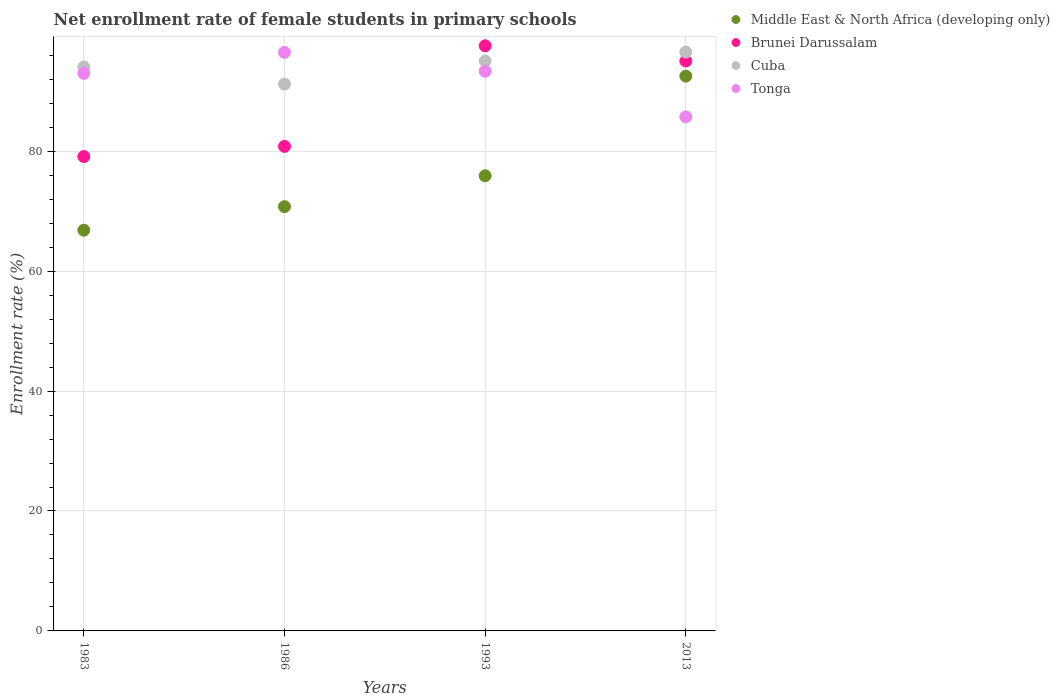Is the number of dotlines equal to the number of legend labels?
Your answer should be compact. Yes. What is the net enrollment rate of female students in primary schools in Brunei Darussalam in 2013?
Your answer should be very brief. 95.04. Across all years, what is the maximum net enrollment rate of female students in primary schools in Brunei Darussalam?
Keep it short and to the point. 97.58. Across all years, what is the minimum net enrollment rate of female students in primary schools in Tonga?
Provide a short and direct response. 85.73. In which year was the net enrollment rate of female students in primary schools in Brunei Darussalam maximum?
Provide a short and direct response. 1993. What is the total net enrollment rate of female students in primary schools in Cuba in the graph?
Provide a succinct answer. 376.82. What is the difference between the net enrollment rate of female students in primary schools in Tonga in 1993 and that in 2013?
Make the answer very short. 7.61. What is the difference between the net enrollment rate of female students in primary schools in Middle East & North Africa (developing only) in 1993 and the net enrollment rate of female students in primary schools in Cuba in 2013?
Your response must be concise. -20.64. What is the average net enrollment rate of female students in primary schools in Cuba per year?
Your response must be concise. 94.21. In the year 1986, what is the difference between the net enrollment rate of female students in primary schools in Cuba and net enrollment rate of female students in primary schools in Middle East & North Africa (developing only)?
Keep it short and to the point. 20.44. In how many years, is the net enrollment rate of female students in primary schools in Cuba greater than 36 %?
Make the answer very short. 4. What is the ratio of the net enrollment rate of female students in primary schools in Tonga in 1986 to that in 1993?
Give a very brief answer. 1.03. What is the difference between the highest and the second highest net enrollment rate of female students in primary schools in Tonga?
Provide a succinct answer. 3.15. What is the difference between the highest and the lowest net enrollment rate of female students in primary schools in Middle East & North Africa (developing only)?
Your response must be concise. 25.69. Is the sum of the net enrollment rate of female students in primary schools in Cuba in 1983 and 2013 greater than the maximum net enrollment rate of female students in primary schools in Brunei Darussalam across all years?
Your answer should be very brief. Yes. Is it the case that in every year, the sum of the net enrollment rate of female students in primary schools in Tonga and net enrollment rate of female students in primary schools in Middle East & North Africa (developing only)  is greater than the sum of net enrollment rate of female students in primary schools in Brunei Darussalam and net enrollment rate of female students in primary schools in Cuba?
Your response must be concise. Yes. Is it the case that in every year, the sum of the net enrollment rate of female students in primary schools in Middle East & North Africa (developing only) and net enrollment rate of female students in primary schools in Brunei Darussalam  is greater than the net enrollment rate of female students in primary schools in Tonga?
Your response must be concise. Yes. Does the net enrollment rate of female students in primary schools in Brunei Darussalam monotonically increase over the years?
Your response must be concise. No. Is the net enrollment rate of female students in primary schools in Cuba strictly less than the net enrollment rate of female students in primary schools in Tonga over the years?
Offer a very short reply. No. How many dotlines are there?
Give a very brief answer. 4. How many years are there in the graph?
Your answer should be compact. 4. Does the graph contain grids?
Your response must be concise. Yes. How are the legend labels stacked?
Your answer should be very brief. Vertical. What is the title of the graph?
Provide a succinct answer. Net enrollment rate of female students in primary schools. Does "Portugal" appear as one of the legend labels in the graph?
Ensure brevity in your answer.  No. What is the label or title of the Y-axis?
Give a very brief answer. Enrollment rate (%). What is the Enrollment rate (%) in Middle East & North Africa (developing only) in 1983?
Provide a short and direct response. 66.83. What is the Enrollment rate (%) in Brunei Darussalam in 1983?
Your response must be concise. 79.11. What is the Enrollment rate (%) in Cuba in 1983?
Make the answer very short. 94.05. What is the Enrollment rate (%) of Tonga in 1983?
Keep it short and to the point. 92.98. What is the Enrollment rate (%) in Middle East & North Africa (developing only) in 1986?
Keep it short and to the point. 70.76. What is the Enrollment rate (%) in Brunei Darussalam in 1986?
Keep it short and to the point. 80.81. What is the Enrollment rate (%) in Cuba in 1986?
Offer a very short reply. 91.2. What is the Enrollment rate (%) in Tonga in 1986?
Offer a terse response. 96.49. What is the Enrollment rate (%) of Middle East & North Africa (developing only) in 1993?
Keep it short and to the point. 75.91. What is the Enrollment rate (%) of Brunei Darussalam in 1993?
Your response must be concise. 97.58. What is the Enrollment rate (%) in Cuba in 1993?
Your answer should be very brief. 95.04. What is the Enrollment rate (%) in Tonga in 1993?
Your response must be concise. 93.34. What is the Enrollment rate (%) in Middle East & North Africa (developing only) in 2013?
Keep it short and to the point. 92.52. What is the Enrollment rate (%) of Brunei Darussalam in 2013?
Provide a short and direct response. 95.04. What is the Enrollment rate (%) of Cuba in 2013?
Give a very brief answer. 96.54. What is the Enrollment rate (%) of Tonga in 2013?
Your answer should be very brief. 85.73. Across all years, what is the maximum Enrollment rate (%) of Middle East & North Africa (developing only)?
Your response must be concise. 92.52. Across all years, what is the maximum Enrollment rate (%) in Brunei Darussalam?
Ensure brevity in your answer.  97.58. Across all years, what is the maximum Enrollment rate (%) of Cuba?
Ensure brevity in your answer.  96.54. Across all years, what is the maximum Enrollment rate (%) in Tonga?
Provide a succinct answer. 96.49. Across all years, what is the minimum Enrollment rate (%) of Middle East & North Africa (developing only)?
Keep it short and to the point. 66.83. Across all years, what is the minimum Enrollment rate (%) in Brunei Darussalam?
Provide a short and direct response. 79.11. Across all years, what is the minimum Enrollment rate (%) in Cuba?
Your answer should be compact. 91.2. Across all years, what is the minimum Enrollment rate (%) of Tonga?
Keep it short and to the point. 85.73. What is the total Enrollment rate (%) of Middle East & North Africa (developing only) in the graph?
Offer a terse response. 306.01. What is the total Enrollment rate (%) of Brunei Darussalam in the graph?
Provide a succinct answer. 352.55. What is the total Enrollment rate (%) of Cuba in the graph?
Keep it short and to the point. 376.82. What is the total Enrollment rate (%) of Tonga in the graph?
Provide a short and direct response. 368.54. What is the difference between the Enrollment rate (%) of Middle East & North Africa (developing only) in 1983 and that in 1986?
Give a very brief answer. -3.93. What is the difference between the Enrollment rate (%) of Brunei Darussalam in 1983 and that in 1986?
Ensure brevity in your answer.  -1.7. What is the difference between the Enrollment rate (%) in Cuba in 1983 and that in 1986?
Keep it short and to the point. 2.85. What is the difference between the Enrollment rate (%) in Tonga in 1983 and that in 1986?
Make the answer very short. -3.51. What is the difference between the Enrollment rate (%) in Middle East & North Africa (developing only) in 1983 and that in 1993?
Provide a succinct answer. -9.08. What is the difference between the Enrollment rate (%) in Brunei Darussalam in 1983 and that in 1993?
Ensure brevity in your answer.  -18.47. What is the difference between the Enrollment rate (%) in Cuba in 1983 and that in 1993?
Provide a succinct answer. -0.99. What is the difference between the Enrollment rate (%) in Tonga in 1983 and that in 1993?
Make the answer very short. -0.36. What is the difference between the Enrollment rate (%) in Middle East & North Africa (developing only) in 1983 and that in 2013?
Keep it short and to the point. -25.69. What is the difference between the Enrollment rate (%) of Brunei Darussalam in 1983 and that in 2013?
Offer a terse response. -15.93. What is the difference between the Enrollment rate (%) of Cuba in 1983 and that in 2013?
Provide a short and direct response. -2.5. What is the difference between the Enrollment rate (%) in Tonga in 1983 and that in 2013?
Offer a very short reply. 7.25. What is the difference between the Enrollment rate (%) in Middle East & North Africa (developing only) in 1986 and that in 1993?
Ensure brevity in your answer.  -5.15. What is the difference between the Enrollment rate (%) in Brunei Darussalam in 1986 and that in 1993?
Provide a succinct answer. -16.77. What is the difference between the Enrollment rate (%) in Cuba in 1986 and that in 1993?
Ensure brevity in your answer.  -3.84. What is the difference between the Enrollment rate (%) in Tonga in 1986 and that in 1993?
Make the answer very short. 3.15. What is the difference between the Enrollment rate (%) in Middle East & North Africa (developing only) in 1986 and that in 2013?
Keep it short and to the point. -21.77. What is the difference between the Enrollment rate (%) in Brunei Darussalam in 1986 and that in 2013?
Make the answer very short. -14.23. What is the difference between the Enrollment rate (%) in Cuba in 1986 and that in 2013?
Provide a short and direct response. -5.35. What is the difference between the Enrollment rate (%) in Tonga in 1986 and that in 2013?
Keep it short and to the point. 10.76. What is the difference between the Enrollment rate (%) of Middle East & North Africa (developing only) in 1993 and that in 2013?
Your answer should be very brief. -16.61. What is the difference between the Enrollment rate (%) in Brunei Darussalam in 1993 and that in 2013?
Keep it short and to the point. 2.54. What is the difference between the Enrollment rate (%) of Cuba in 1993 and that in 2013?
Provide a short and direct response. -1.51. What is the difference between the Enrollment rate (%) in Tonga in 1993 and that in 2013?
Ensure brevity in your answer.  7.61. What is the difference between the Enrollment rate (%) of Middle East & North Africa (developing only) in 1983 and the Enrollment rate (%) of Brunei Darussalam in 1986?
Ensure brevity in your answer.  -13.98. What is the difference between the Enrollment rate (%) of Middle East & North Africa (developing only) in 1983 and the Enrollment rate (%) of Cuba in 1986?
Ensure brevity in your answer.  -24.37. What is the difference between the Enrollment rate (%) in Middle East & North Africa (developing only) in 1983 and the Enrollment rate (%) in Tonga in 1986?
Give a very brief answer. -29.66. What is the difference between the Enrollment rate (%) in Brunei Darussalam in 1983 and the Enrollment rate (%) in Cuba in 1986?
Keep it short and to the point. -12.08. What is the difference between the Enrollment rate (%) of Brunei Darussalam in 1983 and the Enrollment rate (%) of Tonga in 1986?
Provide a short and direct response. -17.38. What is the difference between the Enrollment rate (%) in Cuba in 1983 and the Enrollment rate (%) in Tonga in 1986?
Your response must be concise. -2.44. What is the difference between the Enrollment rate (%) in Middle East & North Africa (developing only) in 1983 and the Enrollment rate (%) in Brunei Darussalam in 1993?
Keep it short and to the point. -30.75. What is the difference between the Enrollment rate (%) of Middle East & North Africa (developing only) in 1983 and the Enrollment rate (%) of Cuba in 1993?
Make the answer very short. -28.21. What is the difference between the Enrollment rate (%) of Middle East & North Africa (developing only) in 1983 and the Enrollment rate (%) of Tonga in 1993?
Give a very brief answer. -26.51. What is the difference between the Enrollment rate (%) in Brunei Darussalam in 1983 and the Enrollment rate (%) in Cuba in 1993?
Your answer should be compact. -15.92. What is the difference between the Enrollment rate (%) in Brunei Darussalam in 1983 and the Enrollment rate (%) in Tonga in 1993?
Offer a terse response. -14.23. What is the difference between the Enrollment rate (%) in Cuba in 1983 and the Enrollment rate (%) in Tonga in 1993?
Keep it short and to the point. 0.71. What is the difference between the Enrollment rate (%) in Middle East & North Africa (developing only) in 1983 and the Enrollment rate (%) in Brunei Darussalam in 2013?
Provide a succinct answer. -28.21. What is the difference between the Enrollment rate (%) of Middle East & North Africa (developing only) in 1983 and the Enrollment rate (%) of Cuba in 2013?
Provide a short and direct response. -29.72. What is the difference between the Enrollment rate (%) in Middle East & North Africa (developing only) in 1983 and the Enrollment rate (%) in Tonga in 2013?
Provide a short and direct response. -18.9. What is the difference between the Enrollment rate (%) of Brunei Darussalam in 1983 and the Enrollment rate (%) of Cuba in 2013?
Keep it short and to the point. -17.43. What is the difference between the Enrollment rate (%) of Brunei Darussalam in 1983 and the Enrollment rate (%) of Tonga in 2013?
Provide a short and direct response. -6.62. What is the difference between the Enrollment rate (%) in Cuba in 1983 and the Enrollment rate (%) in Tonga in 2013?
Offer a very short reply. 8.32. What is the difference between the Enrollment rate (%) in Middle East & North Africa (developing only) in 1986 and the Enrollment rate (%) in Brunei Darussalam in 1993?
Your answer should be compact. -26.83. What is the difference between the Enrollment rate (%) of Middle East & North Africa (developing only) in 1986 and the Enrollment rate (%) of Cuba in 1993?
Provide a short and direct response. -24.28. What is the difference between the Enrollment rate (%) in Middle East & North Africa (developing only) in 1986 and the Enrollment rate (%) in Tonga in 1993?
Your response must be concise. -22.59. What is the difference between the Enrollment rate (%) of Brunei Darussalam in 1986 and the Enrollment rate (%) of Cuba in 1993?
Ensure brevity in your answer.  -14.23. What is the difference between the Enrollment rate (%) of Brunei Darussalam in 1986 and the Enrollment rate (%) of Tonga in 1993?
Offer a very short reply. -12.53. What is the difference between the Enrollment rate (%) in Cuba in 1986 and the Enrollment rate (%) in Tonga in 1993?
Your answer should be compact. -2.15. What is the difference between the Enrollment rate (%) in Middle East & North Africa (developing only) in 1986 and the Enrollment rate (%) in Brunei Darussalam in 2013?
Provide a short and direct response. -24.29. What is the difference between the Enrollment rate (%) in Middle East & North Africa (developing only) in 1986 and the Enrollment rate (%) in Cuba in 2013?
Offer a terse response. -25.79. What is the difference between the Enrollment rate (%) in Middle East & North Africa (developing only) in 1986 and the Enrollment rate (%) in Tonga in 2013?
Give a very brief answer. -14.98. What is the difference between the Enrollment rate (%) of Brunei Darussalam in 1986 and the Enrollment rate (%) of Cuba in 2013?
Ensure brevity in your answer.  -15.74. What is the difference between the Enrollment rate (%) of Brunei Darussalam in 1986 and the Enrollment rate (%) of Tonga in 2013?
Make the answer very short. -4.92. What is the difference between the Enrollment rate (%) in Cuba in 1986 and the Enrollment rate (%) in Tonga in 2013?
Provide a succinct answer. 5.46. What is the difference between the Enrollment rate (%) in Middle East & North Africa (developing only) in 1993 and the Enrollment rate (%) in Brunei Darussalam in 2013?
Provide a short and direct response. -19.13. What is the difference between the Enrollment rate (%) in Middle East & North Africa (developing only) in 1993 and the Enrollment rate (%) in Cuba in 2013?
Make the answer very short. -20.64. What is the difference between the Enrollment rate (%) of Middle East & North Africa (developing only) in 1993 and the Enrollment rate (%) of Tonga in 2013?
Give a very brief answer. -9.82. What is the difference between the Enrollment rate (%) in Brunei Darussalam in 1993 and the Enrollment rate (%) in Cuba in 2013?
Your response must be concise. 1.04. What is the difference between the Enrollment rate (%) of Brunei Darussalam in 1993 and the Enrollment rate (%) of Tonga in 2013?
Give a very brief answer. 11.85. What is the difference between the Enrollment rate (%) in Cuba in 1993 and the Enrollment rate (%) in Tonga in 2013?
Provide a succinct answer. 9.3. What is the average Enrollment rate (%) in Middle East & North Africa (developing only) per year?
Give a very brief answer. 76.5. What is the average Enrollment rate (%) of Brunei Darussalam per year?
Keep it short and to the point. 88.14. What is the average Enrollment rate (%) of Cuba per year?
Provide a short and direct response. 94.21. What is the average Enrollment rate (%) of Tonga per year?
Your response must be concise. 92.14. In the year 1983, what is the difference between the Enrollment rate (%) in Middle East & North Africa (developing only) and Enrollment rate (%) in Brunei Darussalam?
Offer a very short reply. -12.28. In the year 1983, what is the difference between the Enrollment rate (%) in Middle East & North Africa (developing only) and Enrollment rate (%) in Cuba?
Make the answer very short. -27.22. In the year 1983, what is the difference between the Enrollment rate (%) of Middle East & North Africa (developing only) and Enrollment rate (%) of Tonga?
Your answer should be compact. -26.15. In the year 1983, what is the difference between the Enrollment rate (%) in Brunei Darussalam and Enrollment rate (%) in Cuba?
Make the answer very short. -14.94. In the year 1983, what is the difference between the Enrollment rate (%) in Brunei Darussalam and Enrollment rate (%) in Tonga?
Offer a terse response. -13.87. In the year 1983, what is the difference between the Enrollment rate (%) in Cuba and Enrollment rate (%) in Tonga?
Provide a succinct answer. 1.07. In the year 1986, what is the difference between the Enrollment rate (%) in Middle East & North Africa (developing only) and Enrollment rate (%) in Brunei Darussalam?
Ensure brevity in your answer.  -10.05. In the year 1986, what is the difference between the Enrollment rate (%) of Middle East & North Africa (developing only) and Enrollment rate (%) of Cuba?
Provide a succinct answer. -20.44. In the year 1986, what is the difference between the Enrollment rate (%) of Middle East & North Africa (developing only) and Enrollment rate (%) of Tonga?
Provide a succinct answer. -25.73. In the year 1986, what is the difference between the Enrollment rate (%) in Brunei Darussalam and Enrollment rate (%) in Cuba?
Offer a terse response. -10.39. In the year 1986, what is the difference between the Enrollment rate (%) of Brunei Darussalam and Enrollment rate (%) of Tonga?
Ensure brevity in your answer.  -15.68. In the year 1986, what is the difference between the Enrollment rate (%) of Cuba and Enrollment rate (%) of Tonga?
Keep it short and to the point. -5.29. In the year 1993, what is the difference between the Enrollment rate (%) in Middle East & North Africa (developing only) and Enrollment rate (%) in Brunei Darussalam?
Your answer should be compact. -21.68. In the year 1993, what is the difference between the Enrollment rate (%) in Middle East & North Africa (developing only) and Enrollment rate (%) in Cuba?
Give a very brief answer. -19.13. In the year 1993, what is the difference between the Enrollment rate (%) of Middle East & North Africa (developing only) and Enrollment rate (%) of Tonga?
Provide a short and direct response. -17.43. In the year 1993, what is the difference between the Enrollment rate (%) of Brunei Darussalam and Enrollment rate (%) of Cuba?
Give a very brief answer. 2.55. In the year 1993, what is the difference between the Enrollment rate (%) of Brunei Darussalam and Enrollment rate (%) of Tonga?
Your response must be concise. 4.24. In the year 1993, what is the difference between the Enrollment rate (%) in Cuba and Enrollment rate (%) in Tonga?
Offer a terse response. 1.69. In the year 2013, what is the difference between the Enrollment rate (%) of Middle East & North Africa (developing only) and Enrollment rate (%) of Brunei Darussalam?
Your response must be concise. -2.52. In the year 2013, what is the difference between the Enrollment rate (%) in Middle East & North Africa (developing only) and Enrollment rate (%) in Cuba?
Provide a short and direct response. -4.02. In the year 2013, what is the difference between the Enrollment rate (%) of Middle East & North Africa (developing only) and Enrollment rate (%) of Tonga?
Offer a terse response. 6.79. In the year 2013, what is the difference between the Enrollment rate (%) of Brunei Darussalam and Enrollment rate (%) of Cuba?
Give a very brief answer. -1.5. In the year 2013, what is the difference between the Enrollment rate (%) in Brunei Darussalam and Enrollment rate (%) in Tonga?
Give a very brief answer. 9.31. In the year 2013, what is the difference between the Enrollment rate (%) of Cuba and Enrollment rate (%) of Tonga?
Keep it short and to the point. 10.81. What is the ratio of the Enrollment rate (%) of Middle East & North Africa (developing only) in 1983 to that in 1986?
Offer a terse response. 0.94. What is the ratio of the Enrollment rate (%) in Brunei Darussalam in 1983 to that in 1986?
Keep it short and to the point. 0.98. What is the ratio of the Enrollment rate (%) of Cuba in 1983 to that in 1986?
Provide a succinct answer. 1.03. What is the ratio of the Enrollment rate (%) in Tonga in 1983 to that in 1986?
Offer a very short reply. 0.96. What is the ratio of the Enrollment rate (%) in Middle East & North Africa (developing only) in 1983 to that in 1993?
Your answer should be compact. 0.88. What is the ratio of the Enrollment rate (%) in Brunei Darussalam in 1983 to that in 1993?
Provide a succinct answer. 0.81. What is the ratio of the Enrollment rate (%) in Middle East & North Africa (developing only) in 1983 to that in 2013?
Keep it short and to the point. 0.72. What is the ratio of the Enrollment rate (%) of Brunei Darussalam in 1983 to that in 2013?
Ensure brevity in your answer.  0.83. What is the ratio of the Enrollment rate (%) in Cuba in 1983 to that in 2013?
Give a very brief answer. 0.97. What is the ratio of the Enrollment rate (%) in Tonga in 1983 to that in 2013?
Give a very brief answer. 1.08. What is the ratio of the Enrollment rate (%) in Middle East & North Africa (developing only) in 1986 to that in 1993?
Keep it short and to the point. 0.93. What is the ratio of the Enrollment rate (%) of Brunei Darussalam in 1986 to that in 1993?
Your answer should be very brief. 0.83. What is the ratio of the Enrollment rate (%) in Cuba in 1986 to that in 1993?
Offer a terse response. 0.96. What is the ratio of the Enrollment rate (%) in Tonga in 1986 to that in 1993?
Offer a terse response. 1.03. What is the ratio of the Enrollment rate (%) of Middle East & North Africa (developing only) in 1986 to that in 2013?
Give a very brief answer. 0.76. What is the ratio of the Enrollment rate (%) of Brunei Darussalam in 1986 to that in 2013?
Provide a succinct answer. 0.85. What is the ratio of the Enrollment rate (%) in Cuba in 1986 to that in 2013?
Offer a very short reply. 0.94. What is the ratio of the Enrollment rate (%) in Tonga in 1986 to that in 2013?
Keep it short and to the point. 1.13. What is the ratio of the Enrollment rate (%) in Middle East & North Africa (developing only) in 1993 to that in 2013?
Provide a succinct answer. 0.82. What is the ratio of the Enrollment rate (%) in Brunei Darussalam in 1993 to that in 2013?
Your response must be concise. 1.03. What is the ratio of the Enrollment rate (%) of Cuba in 1993 to that in 2013?
Your response must be concise. 0.98. What is the ratio of the Enrollment rate (%) of Tonga in 1993 to that in 2013?
Provide a succinct answer. 1.09. What is the difference between the highest and the second highest Enrollment rate (%) of Middle East & North Africa (developing only)?
Offer a very short reply. 16.61. What is the difference between the highest and the second highest Enrollment rate (%) in Brunei Darussalam?
Your response must be concise. 2.54. What is the difference between the highest and the second highest Enrollment rate (%) in Cuba?
Make the answer very short. 1.51. What is the difference between the highest and the second highest Enrollment rate (%) in Tonga?
Offer a very short reply. 3.15. What is the difference between the highest and the lowest Enrollment rate (%) in Middle East & North Africa (developing only)?
Your response must be concise. 25.69. What is the difference between the highest and the lowest Enrollment rate (%) in Brunei Darussalam?
Provide a succinct answer. 18.47. What is the difference between the highest and the lowest Enrollment rate (%) in Cuba?
Your answer should be compact. 5.35. What is the difference between the highest and the lowest Enrollment rate (%) in Tonga?
Provide a succinct answer. 10.76. 